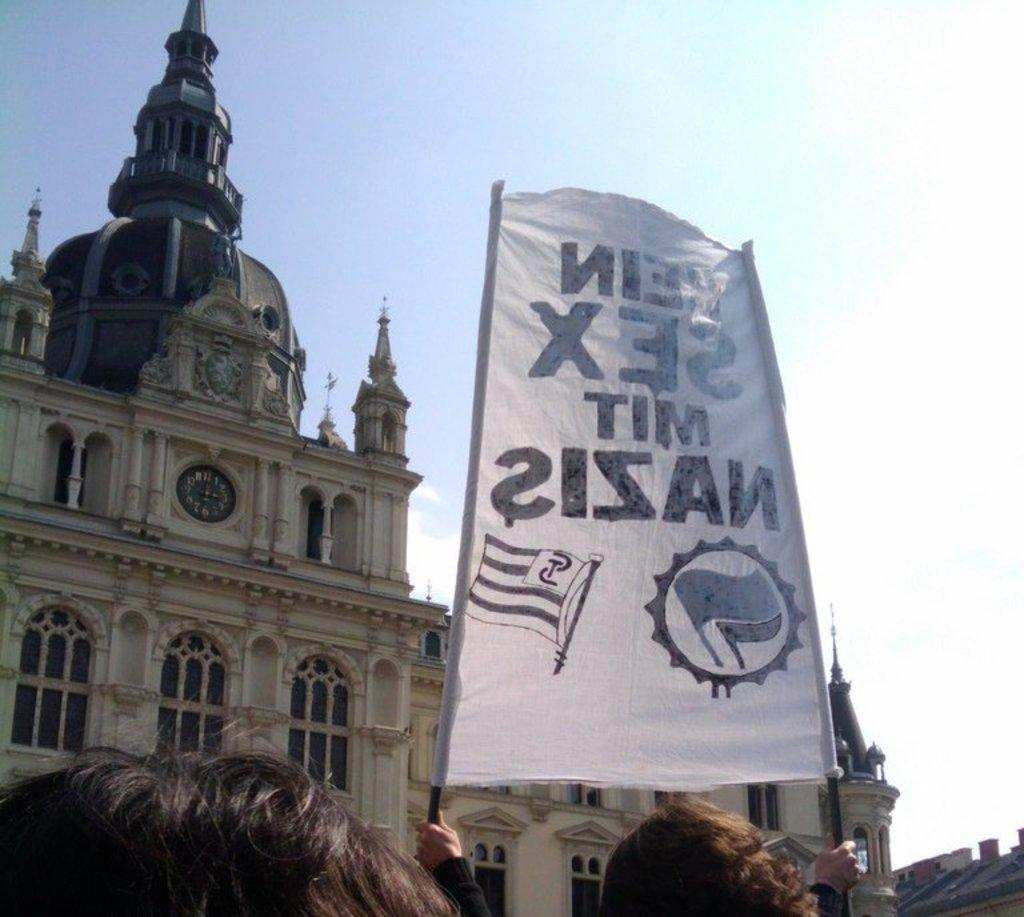What type of structure is located on the left side of the image? There is a castle on the left side of the image. What are the people in the image doing? The people in the image are holding banners. What is visible in the background of the image? The sky is visible in the image. Can you tell me how many icicles are hanging from the castle in the image? There is no mention of icicles in the image, so it is not possible to determine their presence or quantity. 